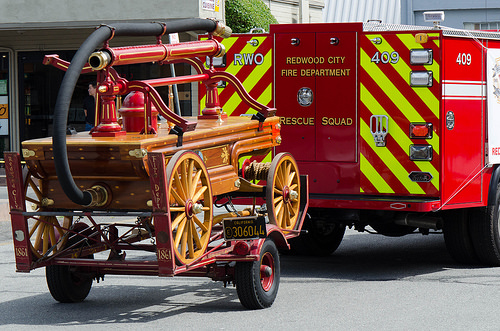<image>
Is the truck next to the road? No. The truck is not positioned next to the road. They are located in different areas of the scene. 